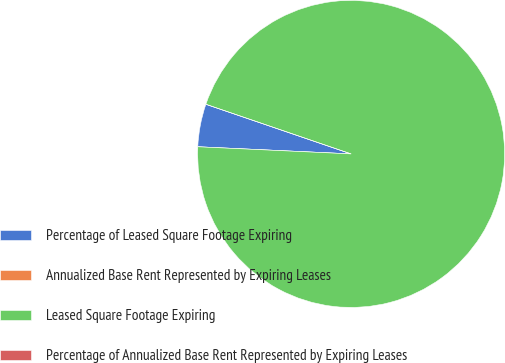Convert chart. <chart><loc_0><loc_0><loc_500><loc_500><pie_chart><fcel>Percentage of Leased Square Footage Expiring<fcel>Annualized Base Rent Represented by Expiring Leases<fcel>Leased Square Footage Expiring<fcel>Percentage of Annualized Base Rent Represented by Expiring Leases<nl><fcel>4.5%<fcel>0.0%<fcel>95.5%<fcel>0.0%<nl></chart> 